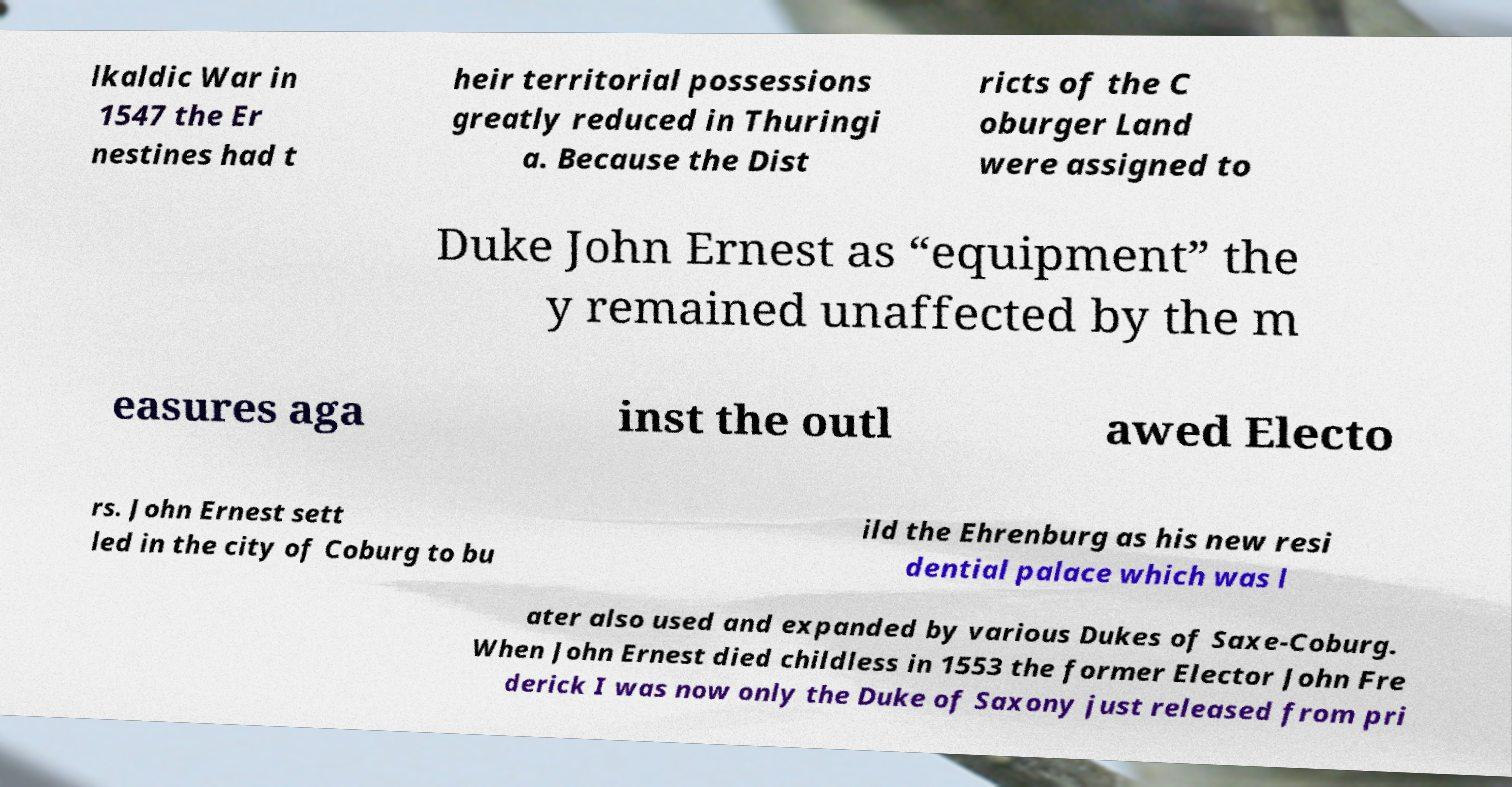Could you extract and type out the text from this image? lkaldic War in 1547 the Er nestines had t heir territorial possessions greatly reduced in Thuringi a. Because the Dist ricts of the C oburger Land were assigned to Duke John Ernest as “equipment” the y remained unaffected by the m easures aga inst the outl awed Electo rs. John Ernest sett led in the city of Coburg to bu ild the Ehrenburg as his new resi dential palace which was l ater also used and expanded by various Dukes of Saxe-Coburg. When John Ernest died childless in 1553 the former Elector John Fre derick I was now only the Duke of Saxony just released from pri 